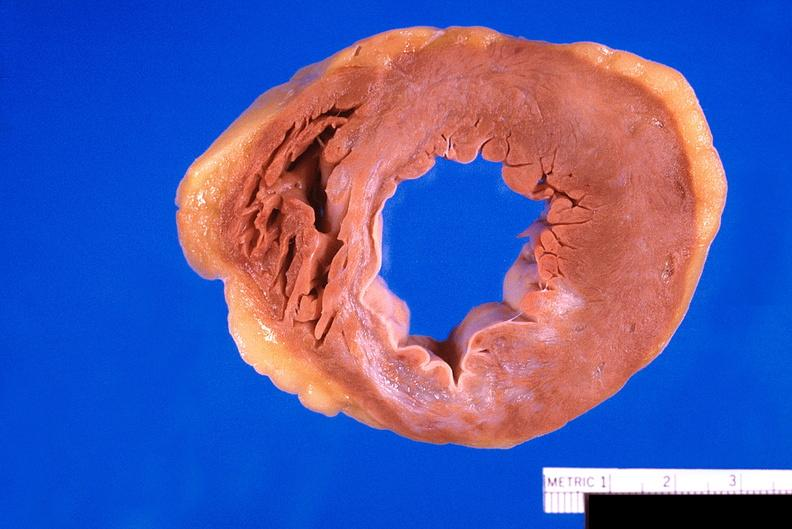what is present?
Answer the question using a single word or phrase. Cardiovascular 